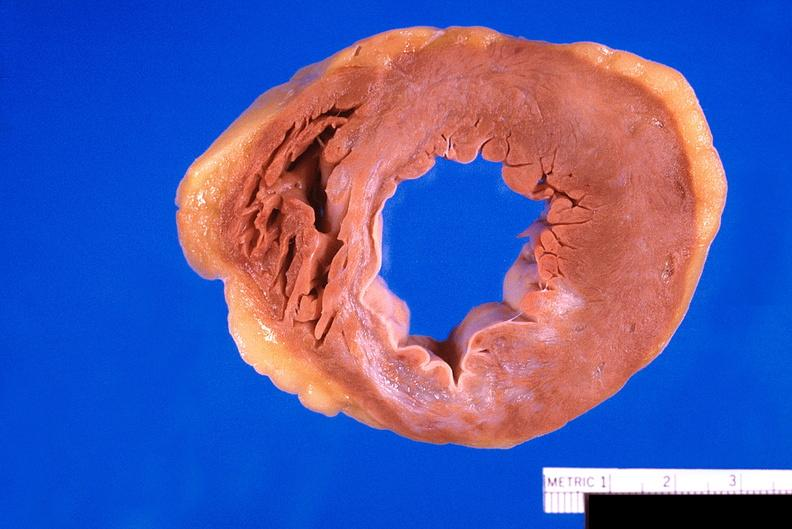what is present?
Answer the question using a single word or phrase. Cardiovascular 